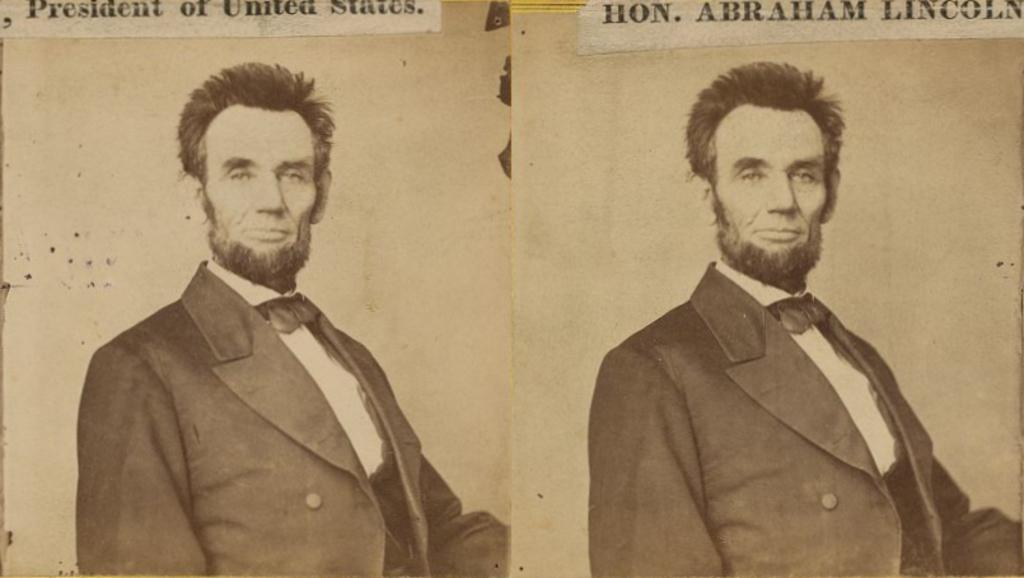What type of image is being described? The image is edited and contains a collage of a person. What else can be found in the image besides the person? There is text visible in the image. How does the scarecrow feel about the taste of the collage in the image? There is no scarecrow present in the image, and therefore no such interaction can be observed. 